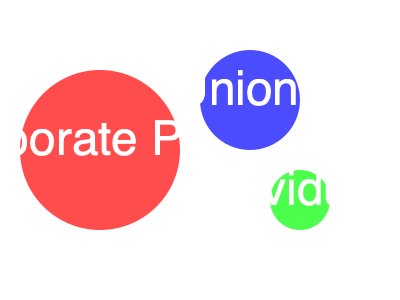In the diagram representing campaign donations to a local Anaheim politician, which source contributed the largest amount, and how much larger is it compared to the smallest contribution source? To determine the relative sizes of the contributions, we need to compare the areas of the circles:

1. The areas of circles are proportional to the square of their radii.

2. Radii of the circles:
   - Corporate PACs: 80 units
   - Unions: 50 units
   - Individuals: 30 units

3. Calculate the areas (using $A = \pi r^2$):
   - Corporate PACs: $A_1 = \pi (80)^2 = 20,106.19$ square units
   - Unions: $A_2 = \pi (50)^2 = 7,853.98$ square units
   - Individuals: $A_3 = \pi (30)^2 = 2,827.43$ square units

4. The largest contribution is from Corporate PACs (red circle).

5. To find how much larger it is than the smallest (Individuals):
   $\frac{A_1}{A_3} = \frac{20,106.19}{2,827.43} \approx 7.11$

Therefore, the Corporate PACs' contribution is approximately 7.11 times larger than the contribution from Individuals.
Answer: Corporate PACs; 7.11 times larger 